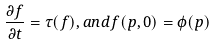Convert formula to latex. <formula><loc_0><loc_0><loc_500><loc_500>\frac { \partial f } { \partial t } = \tau ( f ) , a n d f ( p , 0 ) = \phi ( p )</formula> 